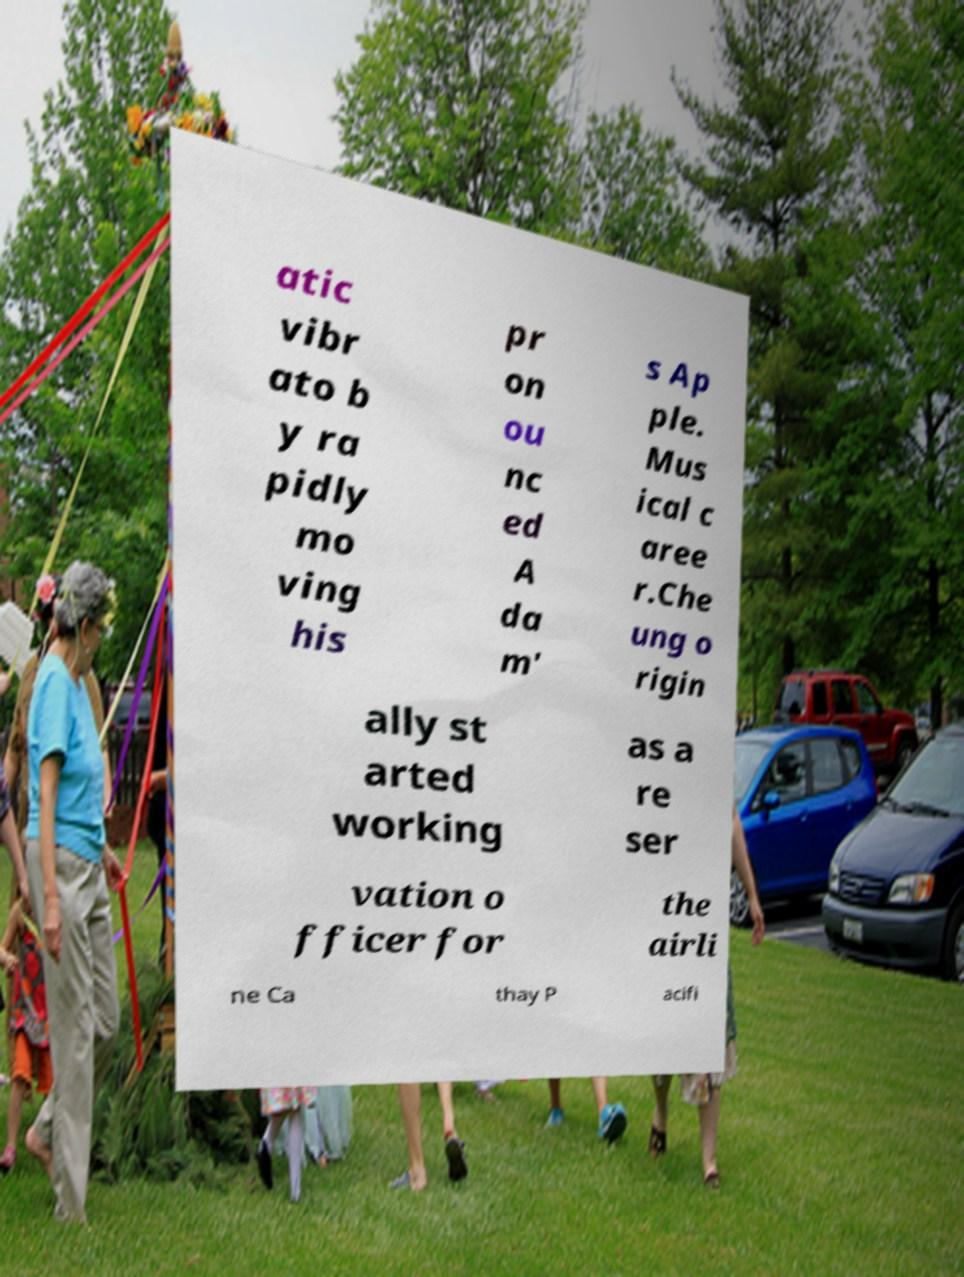There's text embedded in this image that I need extracted. Can you transcribe it verbatim? atic vibr ato b y ra pidly mo ving his pr on ou nc ed A da m' s Ap ple. Mus ical c aree r.Che ung o rigin ally st arted working as a re ser vation o fficer for the airli ne Ca thay P acifi 